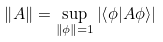<formula> <loc_0><loc_0><loc_500><loc_500>\left \| A \right \| = \sup _ { \left \| \phi \right \| = 1 } \left | \left \langle \phi | A \phi \right \rangle \right |</formula> 